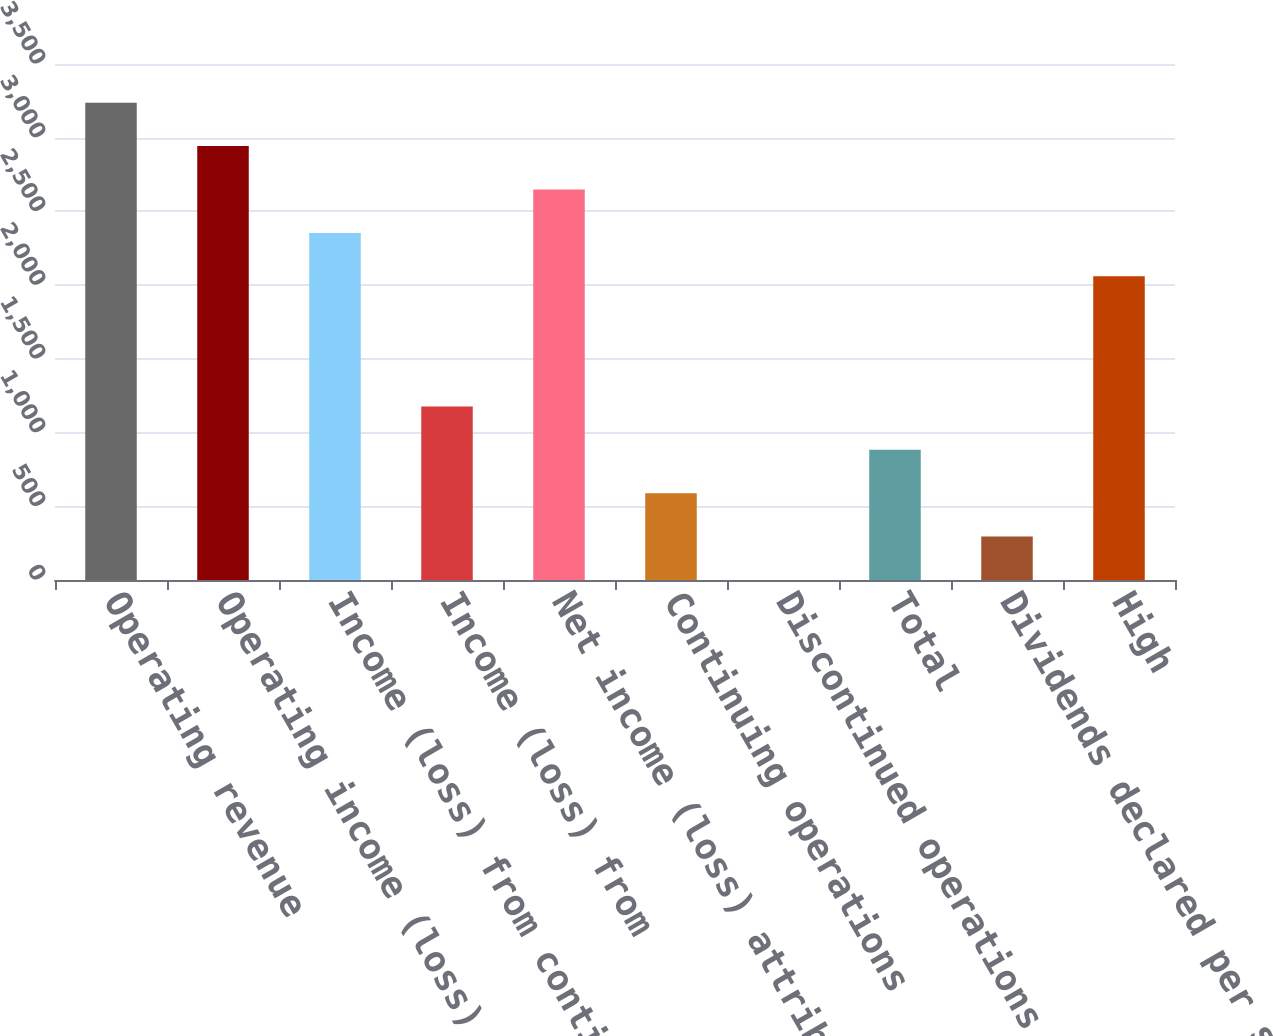Convert chart to OTSL. <chart><loc_0><loc_0><loc_500><loc_500><bar_chart><fcel>Operating revenue<fcel>Operating income (loss)<fcel>Income (loss) from continuing<fcel>Income (loss) from<fcel>Net income (loss) attributable<fcel>Continuing operations<fcel>Discontinued operations<fcel>Total<fcel>Dividends declared per share<fcel>High<nl><fcel>3237.3<fcel>2943.01<fcel>2354.43<fcel>1177.27<fcel>2648.72<fcel>588.69<fcel>0.11<fcel>882.98<fcel>294.4<fcel>2060.14<nl></chart> 